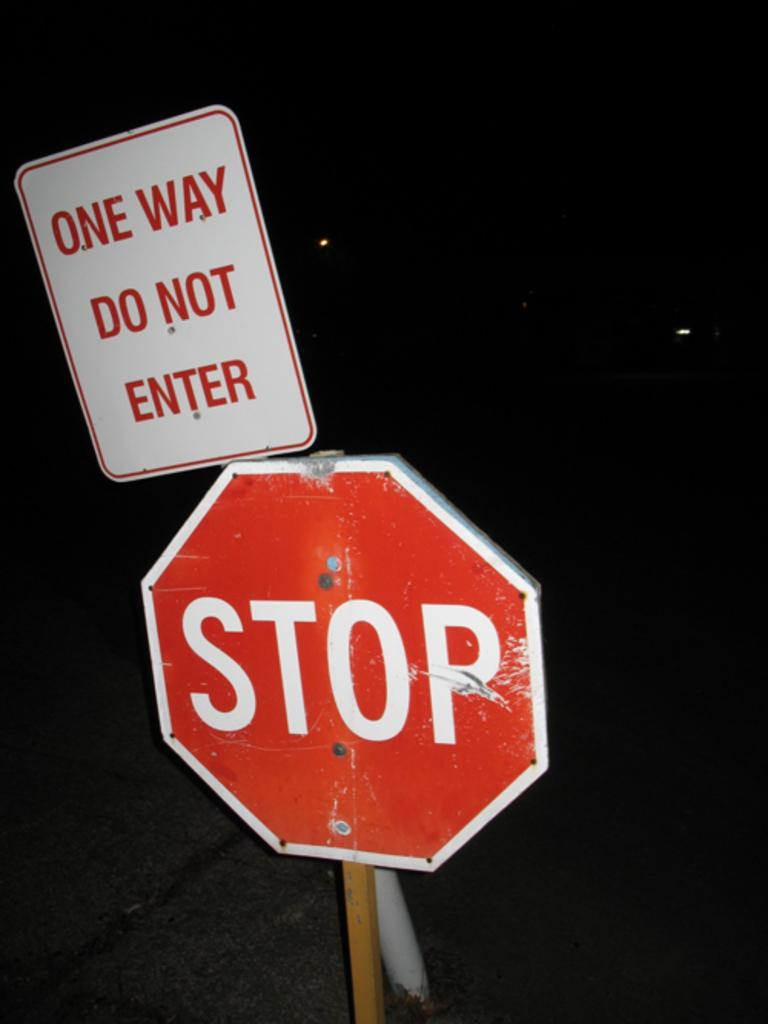Provide a one-sentence caption for the provided image. A sign behind a stop sign indicates a one way direction. 